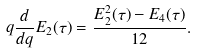<formula> <loc_0><loc_0><loc_500><loc_500>q \frac { d } { d q } E _ { 2 } ( \tau ) = \frac { E _ { 2 } ^ { 2 } ( \tau ) - E _ { 4 } ( \tau ) } { 1 2 } .</formula> 